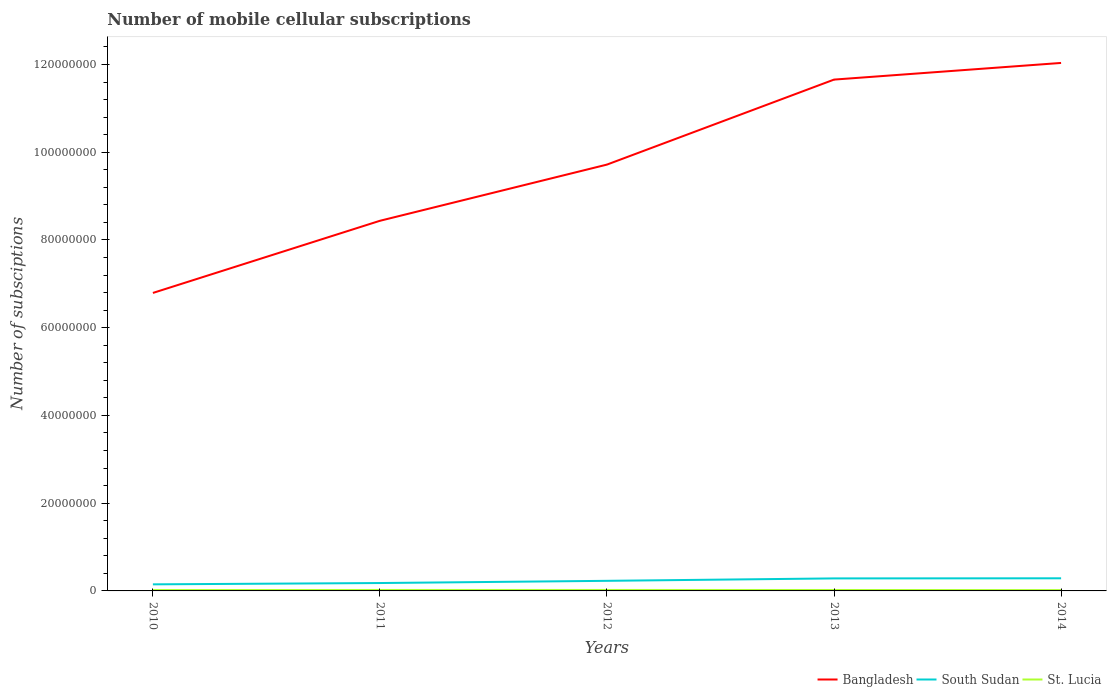How many different coloured lines are there?
Offer a terse response. 3. Does the line corresponding to St. Lucia intersect with the line corresponding to South Sudan?
Provide a short and direct response. No. Is the number of lines equal to the number of legend labels?
Your response must be concise. Yes. Across all years, what is the maximum number of mobile cellular subscriptions in St. Lucia?
Keep it short and to the point. 1.88e+05. What is the total number of mobile cellular subscriptions in St. Lucia in the graph?
Give a very brief answer. 2.82e+04. What is the difference between the highest and the second highest number of mobile cellular subscriptions in South Sudan?
Provide a succinct answer. 1.38e+06. How many lines are there?
Provide a short and direct response. 3. Are the values on the major ticks of Y-axis written in scientific E-notation?
Offer a very short reply. No. Where does the legend appear in the graph?
Offer a terse response. Bottom right. How many legend labels are there?
Your answer should be very brief. 3. What is the title of the graph?
Provide a short and direct response. Number of mobile cellular subscriptions. Does "Aruba" appear as one of the legend labels in the graph?
Keep it short and to the point. No. What is the label or title of the X-axis?
Offer a very short reply. Years. What is the label or title of the Y-axis?
Offer a very short reply. Number of subsciptions. What is the Number of subsciptions in Bangladesh in 2010?
Provide a short and direct response. 6.79e+07. What is the Number of subsciptions of South Sudan in 2010?
Give a very brief answer. 1.50e+06. What is the Number of subsciptions in St. Lucia in 2010?
Give a very brief answer. 1.98e+05. What is the Number of subsciptions of Bangladesh in 2011?
Your answer should be compact. 8.44e+07. What is the Number of subsciptions of South Sudan in 2011?
Make the answer very short. 1.80e+06. What is the Number of subsciptions in St. Lucia in 2011?
Offer a very short reply. 2.17e+05. What is the Number of subsciptions in Bangladesh in 2012?
Your answer should be very brief. 9.72e+07. What is the Number of subsciptions in South Sudan in 2012?
Your answer should be very brief. 2.30e+06. What is the Number of subsciptions in St. Lucia in 2012?
Your response must be concise. 2.16e+05. What is the Number of subsciptions of Bangladesh in 2013?
Give a very brief answer. 1.17e+08. What is the Number of subsciptions in South Sudan in 2013?
Offer a very short reply. 2.85e+06. What is the Number of subsciptions of St. Lucia in 2013?
Your response must be concise. 2.12e+05. What is the Number of subsciptions of Bangladesh in 2014?
Make the answer very short. 1.20e+08. What is the Number of subsciptions of South Sudan in 2014?
Offer a terse response. 2.88e+06. What is the Number of subsciptions of St. Lucia in 2014?
Offer a very short reply. 1.88e+05. Across all years, what is the maximum Number of subsciptions of Bangladesh?
Your answer should be very brief. 1.20e+08. Across all years, what is the maximum Number of subsciptions in South Sudan?
Your answer should be compact. 2.88e+06. Across all years, what is the maximum Number of subsciptions in St. Lucia?
Your answer should be very brief. 2.17e+05. Across all years, what is the minimum Number of subsciptions in Bangladesh?
Offer a very short reply. 6.79e+07. Across all years, what is the minimum Number of subsciptions in South Sudan?
Give a very brief answer. 1.50e+06. Across all years, what is the minimum Number of subsciptions in St. Lucia?
Give a very brief answer. 1.88e+05. What is the total Number of subsciptions in Bangladesh in the graph?
Your answer should be very brief. 4.86e+08. What is the total Number of subsciptions of South Sudan in the graph?
Provide a short and direct response. 1.13e+07. What is the total Number of subsciptions of St. Lucia in the graph?
Provide a succinct answer. 1.03e+06. What is the difference between the Number of subsciptions of Bangladesh in 2010 and that in 2011?
Your response must be concise. -1.64e+07. What is the difference between the Number of subsciptions of South Sudan in 2010 and that in 2011?
Provide a succinct answer. -3.00e+05. What is the difference between the Number of subsciptions of St. Lucia in 2010 and that in 2011?
Your answer should be very brief. -1.83e+04. What is the difference between the Number of subsciptions in Bangladesh in 2010 and that in 2012?
Give a very brief answer. -2.93e+07. What is the difference between the Number of subsciptions of South Sudan in 2010 and that in 2012?
Your answer should be very brief. -8.00e+05. What is the difference between the Number of subsciptions of St. Lucia in 2010 and that in 2012?
Provide a succinct answer. -1.78e+04. What is the difference between the Number of subsciptions of Bangladesh in 2010 and that in 2013?
Give a very brief answer. -4.86e+07. What is the difference between the Number of subsciptions in South Sudan in 2010 and that in 2013?
Your response must be concise. -1.35e+06. What is the difference between the Number of subsciptions of St. Lucia in 2010 and that in 2013?
Keep it short and to the point. -1.38e+04. What is the difference between the Number of subsciptions in Bangladesh in 2010 and that in 2014?
Make the answer very short. -5.24e+07. What is the difference between the Number of subsciptions of South Sudan in 2010 and that in 2014?
Ensure brevity in your answer.  -1.38e+06. What is the difference between the Number of subsciptions in St. Lucia in 2010 and that in 2014?
Your answer should be very brief. 9861. What is the difference between the Number of subsciptions of Bangladesh in 2011 and that in 2012?
Your answer should be compact. -1.28e+07. What is the difference between the Number of subsciptions in South Sudan in 2011 and that in 2012?
Your answer should be compact. -5.00e+05. What is the difference between the Number of subsciptions of St. Lucia in 2011 and that in 2012?
Your response must be concise. 530. What is the difference between the Number of subsciptions in Bangladesh in 2011 and that in 2013?
Offer a terse response. -3.22e+07. What is the difference between the Number of subsciptions of South Sudan in 2011 and that in 2013?
Offer a terse response. -1.05e+06. What is the difference between the Number of subsciptions of St. Lucia in 2011 and that in 2013?
Offer a terse response. 4530. What is the difference between the Number of subsciptions of Bangladesh in 2011 and that in 2014?
Offer a terse response. -3.60e+07. What is the difference between the Number of subsciptions of South Sudan in 2011 and that in 2014?
Provide a succinct answer. -1.08e+06. What is the difference between the Number of subsciptions in St. Lucia in 2011 and that in 2014?
Your answer should be compact. 2.82e+04. What is the difference between the Number of subsciptions in Bangladesh in 2012 and that in 2013?
Ensure brevity in your answer.  -1.94e+07. What is the difference between the Number of subsciptions of South Sudan in 2012 and that in 2013?
Your answer should be compact. -5.53e+05. What is the difference between the Number of subsciptions of St. Lucia in 2012 and that in 2013?
Your answer should be very brief. 4000. What is the difference between the Number of subsciptions of Bangladesh in 2012 and that in 2014?
Give a very brief answer. -2.32e+07. What is the difference between the Number of subsciptions in South Sudan in 2012 and that in 2014?
Your response must be concise. -5.76e+05. What is the difference between the Number of subsciptions in St. Lucia in 2012 and that in 2014?
Keep it short and to the point. 2.76e+04. What is the difference between the Number of subsciptions of Bangladesh in 2013 and that in 2014?
Give a very brief answer. -3.80e+06. What is the difference between the Number of subsciptions in South Sudan in 2013 and that in 2014?
Your response must be concise. -2.29e+04. What is the difference between the Number of subsciptions of St. Lucia in 2013 and that in 2014?
Your answer should be compact. 2.36e+04. What is the difference between the Number of subsciptions in Bangladesh in 2010 and the Number of subsciptions in South Sudan in 2011?
Your response must be concise. 6.61e+07. What is the difference between the Number of subsciptions in Bangladesh in 2010 and the Number of subsciptions in St. Lucia in 2011?
Provide a short and direct response. 6.77e+07. What is the difference between the Number of subsciptions in South Sudan in 2010 and the Number of subsciptions in St. Lucia in 2011?
Your response must be concise. 1.28e+06. What is the difference between the Number of subsciptions in Bangladesh in 2010 and the Number of subsciptions in South Sudan in 2012?
Your answer should be very brief. 6.56e+07. What is the difference between the Number of subsciptions in Bangladesh in 2010 and the Number of subsciptions in St. Lucia in 2012?
Your response must be concise. 6.77e+07. What is the difference between the Number of subsciptions in South Sudan in 2010 and the Number of subsciptions in St. Lucia in 2012?
Your answer should be compact. 1.28e+06. What is the difference between the Number of subsciptions in Bangladesh in 2010 and the Number of subsciptions in South Sudan in 2013?
Keep it short and to the point. 6.51e+07. What is the difference between the Number of subsciptions of Bangladesh in 2010 and the Number of subsciptions of St. Lucia in 2013?
Provide a short and direct response. 6.77e+07. What is the difference between the Number of subsciptions of South Sudan in 2010 and the Number of subsciptions of St. Lucia in 2013?
Your answer should be very brief. 1.29e+06. What is the difference between the Number of subsciptions of Bangladesh in 2010 and the Number of subsciptions of South Sudan in 2014?
Offer a very short reply. 6.50e+07. What is the difference between the Number of subsciptions of Bangladesh in 2010 and the Number of subsciptions of St. Lucia in 2014?
Offer a terse response. 6.77e+07. What is the difference between the Number of subsciptions in South Sudan in 2010 and the Number of subsciptions in St. Lucia in 2014?
Offer a terse response. 1.31e+06. What is the difference between the Number of subsciptions in Bangladesh in 2011 and the Number of subsciptions in South Sudan in 2012?
Keep it short and to the point. 8.21e+07. What is the difference between the Number of subsciptions in Bangladesh in 2011 and the Number of subsciptions in St. Lucia in 2012?
Your answer should be very brief. 8.42e+07. What is the difference between the Number of subsciptions in South Sudan in 2011 and the Number of subsciptions in St. Lucia in 2012?
Give a very brief answer. 1.58e+06. What is the difference between the Number of subsciptions of Bangladesh in 2011 and the Number of subsciptions of South Sudan in 2013?
Offer a terse response. 8.15e+07. What is the difference between the Number of subsciptions of Bangladesh in 2011 and the Number of subsciptions of St. Lucia in 2013?
Offer a terse response. 8.42e+07. What is the difference between the Number of subsciptions in South Sudan in 2011 and the Number of subsciptions in St. Lucia in 2013?
Ensure brevity in your answer.  1.59e+06. What is the difference between the Number of subsciptions in Bangladesh in 2011 and the Number of subsciptions in South Sudan in 2014?
Your response must be concise. 8.15e+07. What is the difference between the Number of subsciptions of Bangladesh in 2011 and the Number of subsciptions of St. Lucia in 2014?
Your answer should be compact. 8.42e+07. What is the difference between the Number of subsciptions in South Sudan in 2011 and the Number of subsciptions in St. Lucia in 2014?
Your answer should be compact. 1.61e+06. What is the difference between the Number of subsciptions of Bangladesh in 2012 and the Number of subsciptions of South Sudan in 2013?
Your answer should be compact. 9.43e+07. What is the difference between the Number of subsciptions in Bangladesh in 2012 and the Number of subsciptions in St. Lucia in 2013?
Provide a succinct answer. 9.70e+07. What is the difference between the Number of subsciptions in South Sudan in 2012 and the Number of subsciptions in St. Lucia in 2013?
Your response must be concise. 2.09e+06. What is the difference between the Number of subsciptions in Bangladesh in 2012 and the Number of subsciptions in South Sudan in 2014?
Give a very brief answer. 9.43e+07. What is the difference between the Number of subsciptions in Bangladesh in 2012 and the Number of subsciptions in St. Lucia in 2014?
Ensure brevity in your answer.  9.70e+07. What is the difference between the Number of subsciptions in South Sudan in 2012 and the Number of subsciptions in St. Lucia in 2014?
Offer a terse response. 2.11e+06. What is the difference between the Number of subsciptions of Bangladesh in 2013 and the Number of subsciptions of South Sudan in 2014?
Make the answer very short. 1.14e+08. What is the difference between the Number of subsciptions of Bangladesh in 2013 and the Number of subsciptions of St. Lucia in 2014?
Your answer should be compact. 1.16e+08. What is the difference between the Number of subsciptions in South Sudan in 2013 and the Number of subsciptions in St. Lucia in 2014?
Provide a short and direct response. 2.66e+06. What is the average Number of subsciptions of Bangladesh per year?
Provide a short and direct response. 9.73e+07. What is the average Number of subsciptions of South Sudan per year?
Provide a succinct answer. 2.27e+06. What is the average Number of subsciptions of St. Lucia per year?
Give a very brief answer. 2.06e+05. In the year 2010, what is the difference between the Number of subsciptions in Bangladesh and Number of subsciptions in South Sudan?
Offer a terse response. 6.64e+07. In the year 2010, what is the difference between the Number of subsciptions in Bangladesh and Number of subsciptions in St. Lucia?
Give a very brief answer. 6.77e+07. In the year 2010, what is the difference between the Number of subsciptions in South Sudan and Number of subsciptions in St. Lucia?
Your response must be concise. 1.30e+06. In the year 2011, what is the difference between the Number of subsciptions of Bangladesh and Number of subsciptions of South Sudan?
Give a very brief answer. 8.26e+07. In the year 2011, what is the difference between the Number of subsciptions in Bangladesh and Number of subsciptions in St. Lucia?
Offer a very short reply. 8.42e+07. In the year 2011, what is the difference between the Number of subsciptions of South Sudan and Number of subsciptions of St. Lucia?
Give a very brief answer. 1.58e+06. In the year 2012, what is the difference between the Number of subsciptions of Bangladesh and Number of subsciptions of South Sudan?
Provide a short and direct response. 9.49e+07. In the year 2012, what is the difference between the Number of subsciptions in Bangladesh and Number of subsciptions in St. Lucia?
Keep it short and to the point. 9.70e+07. In the year 2012, what is the difference between the Number of subsciptions of South Sudan and Number of subsciptions of St. Lucia?
Ensure brevity in your answer.  2.08e+06. In the year 2013, what is the difference between the Number of subsciptions of Bangladesh and Number of subsciptions of South Sudan?
Provide a short and direct response. 1.14e+08. In the year 2013, what is the difference between the Number of subsciptions in Bangladesh and Number of subsciptions in St. Lucia?
Provide a short and direct response. 1.16e+08. In the year 2013, what is the difference between the Number of subsciptions in South Sudan and Number of subsciptions in St. Lucia?
Your answer should be compact. 2.64e+06. In the year 2014, what is the difference between the Number of subsciptions in Bangladesh and Number of subsciptions in South Sudan?
Provide a succinct answer. 1.17e+08. In the year 2014, what is the difference between the Number of subsciptions of Bangladesh and Number of subsciptions of St. Lucia?
Offer a terse response. 1.20e+08. In the year 2014, what is the difference between the Number of subsciptions of South Sudan and Number of subsciptions of St. Lucia?
Provide a succinct answer. 2.69e+06. What is the ratio of the Number of subsciptions of Bangladesh in 2010 to that in 2011?
Your answer should be very brief. 0.81. What is the ratio of the Number of subsciptions in South Sudan in 2010 to that in 2011?
Provide a short and direct response. 0.83. What is the ratio of the Number of subsciptions in St. Lucia in 2010 to that in 2011?
Offer a terse response. 0.92. What is the ratio of the Number of subsciptions of Bangladesh in 2010 to that in 2012?
Make the answer very short. 0.7. What is the ratio of the Number of subsciptions in South Sudan in 2010 to that in 2012?
Offer a very short reply. 0.65. What is the ratio of the Number of subsciptions in St. Lucia in 2010 to that in 2012?
Keep it short and to the point. 0.92. What is the ratio of the Number of subsciptions of Bangladesh in 2010 to that in 2013?
Your response must be concise. 0.58. What is the ratio of the Number of subsciptions of South Sudan in 2010 to that in 2013?
Ensure brevity in your answer.  0.53. What is the ratio of the Number of subsciptions of St. Lucia in 2010 to that in 2013?
Make the answer very short. 0.94. What is the ratio of the Number of subsciptions in Bangladesh in 2010 to that in 2014?
Your answer should be very brief. 0.56. What is the ratio of the Number of subsciptions of South Sudan in 2010 to that in 2014?
Your answer should be compact. 0.52. What is the ratio of the Number of subsciptions in St. Lucia in 2010 to that in 2014?
Your answer should be compact. 1.05. What is the ratio of the Number of subsciptions of Bangladesh in 2011 to that in 2012?
Ensure brevity in your answer.  0.87. What is the ratio of the Number of subsciptions in South Sudan in 2011 to that in 2012?
Your answer should be very brief. 0.78. What is the ratio of the Number of subsciptions in Bangladesh in 2011 to that in 2013?
Give a very brief answer. 0.72. What is the ratio of the Number of subsciptions in South Sudan in 2011 to that in 2013?
Keep it short and to the point. 0.63. What is the ratio of the Number of subsciptions of St. Lucia in 2011 to that in 2013?
Ensure brevity in your answer.  1.02. What is the ratio of the Number of subsciptions in Bangladesh in 2011 to that in 2014?
Offer a terse response. 0.7. What is the ratio of the Number of subsciptions in South Sudan in 2011 to that in 2014?
Offer a terse response. 0.63. What is the ratio of the Number of subsciptions of St. Lucia in 2011 to that in 2014?
Give a very brief answer. 1.15. What is the ratio of the Number of subsciptions in Bangladesh in 2012 to that in 2013?
Provide a short and direct response. 0.83. What is the ratio of the Number of subsciptions in South Sudan in 2012 to that in 2013?
Offer a very short reply. 0.81. What is the ratio of the Number of subsciptions in St. Lucia in 2012 to that in 2013?
Provide a short and direct response. 1.02. What is the ratio of the Number of subsciptions of Bangladesh in 2012 to that in 2014?
Your answer should be very brief. 0.81. What is the ratio of the Number of subsciptions of South Sudan in 2012 to that in 2014?
Make the answer very short. 0.8. What is the ratio of the Number of subsciptions in St. Lucia in 2012 to that in 2014?
Your answer should be very brief. 1.15. What is the ratio of the Number of subsciptions in Bangladesh in 2013 to that in 2014?
Your answer should be compact. 0.97. What is the ratio of the Number of subsciptions of South Sudan in 2013 to that in 2014?
Your answer should be very brief. 0.99. What is the ratio of the Number of subsciptions in St. Lucia in 2013 to that in 2014?
Make the answer very short. 1.13. What is the difference between the highest and the second highest Number of subsciptions in Bangladesh?
Your answer should be very brief. 3.80e+06. What is the difference between the highest and the second highest Number of subsciptions of South Sudan?
Your answer should be very brief. 2.29e+04. What is the difference between the highest and the second highest Number of subsciptions in St. Lucia?
Provide a succinct answer. 530. What is the difference between the highest and the lowest Number of subsciptions of Bangladesh?
Give a very brief answer. 5.24e+07. What is the difference between the highest and the lowest Number of subsciptions in South Sudan?
Offer a very short reply. 1.38e+06. What is the difference between the highest and the lowest Number of subsciptions in St. Lucia?
Your answer should be compact. 2.82e+04. 